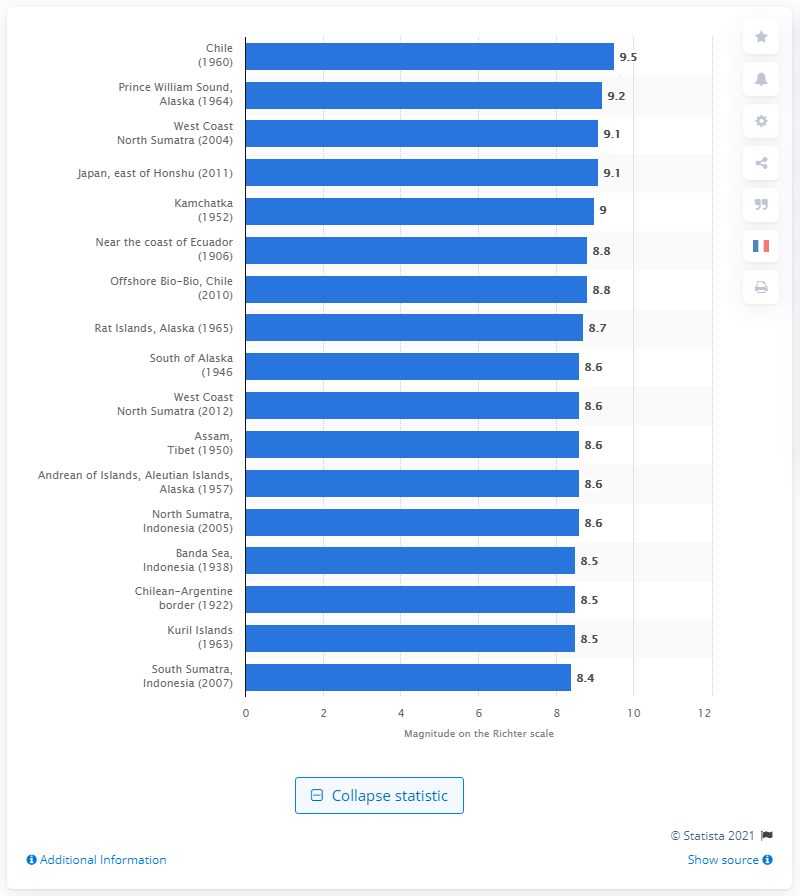Indicate a few pertinent items in this graphic. The largest earthquake measured on the Richter scale was 9.5. 